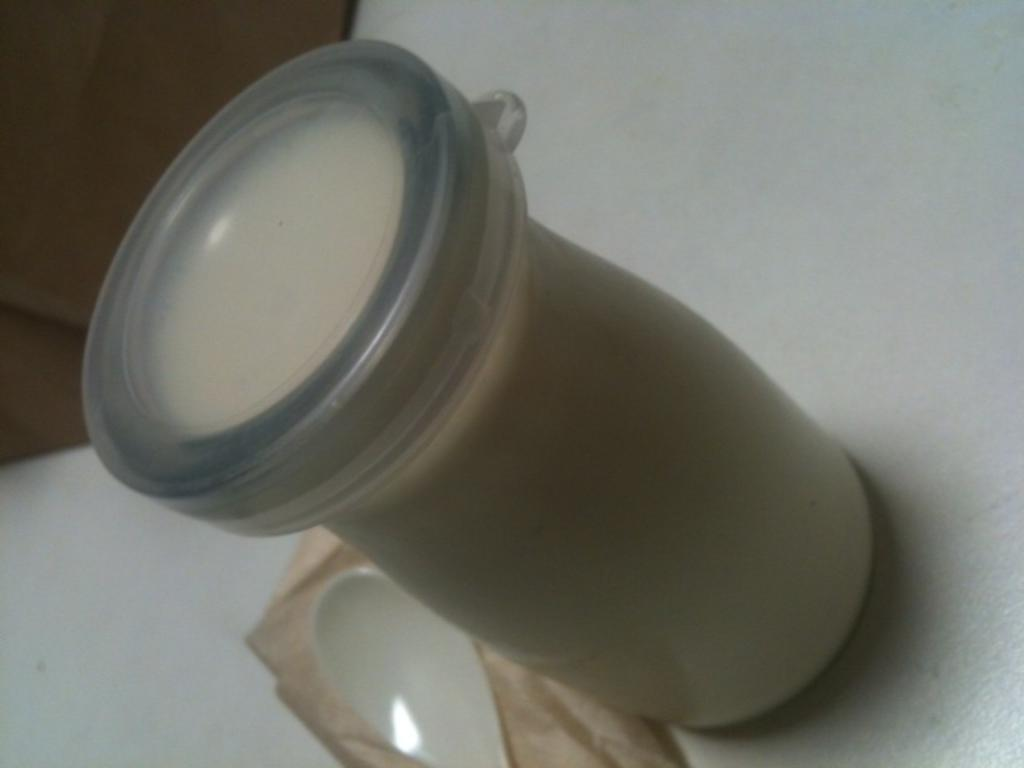What is the color of the surface in the image? The surface in the image is white. What is placed on the white surface? There is a tumbler with milk on the white surface. Does the tumbler have any additional features? Yes, the tumbler has a lid. What utensil can be seen in the image? There is a spoon in the image. What type of slope can be seen in the middle of the image? There is no slope present in the image; it features a white surface with a tumbler and a spoon. How does the rainstorm affect the milk in the tumbler? There is no rainstorm present in the image, so it cannot affect the milk in the tumbler. 